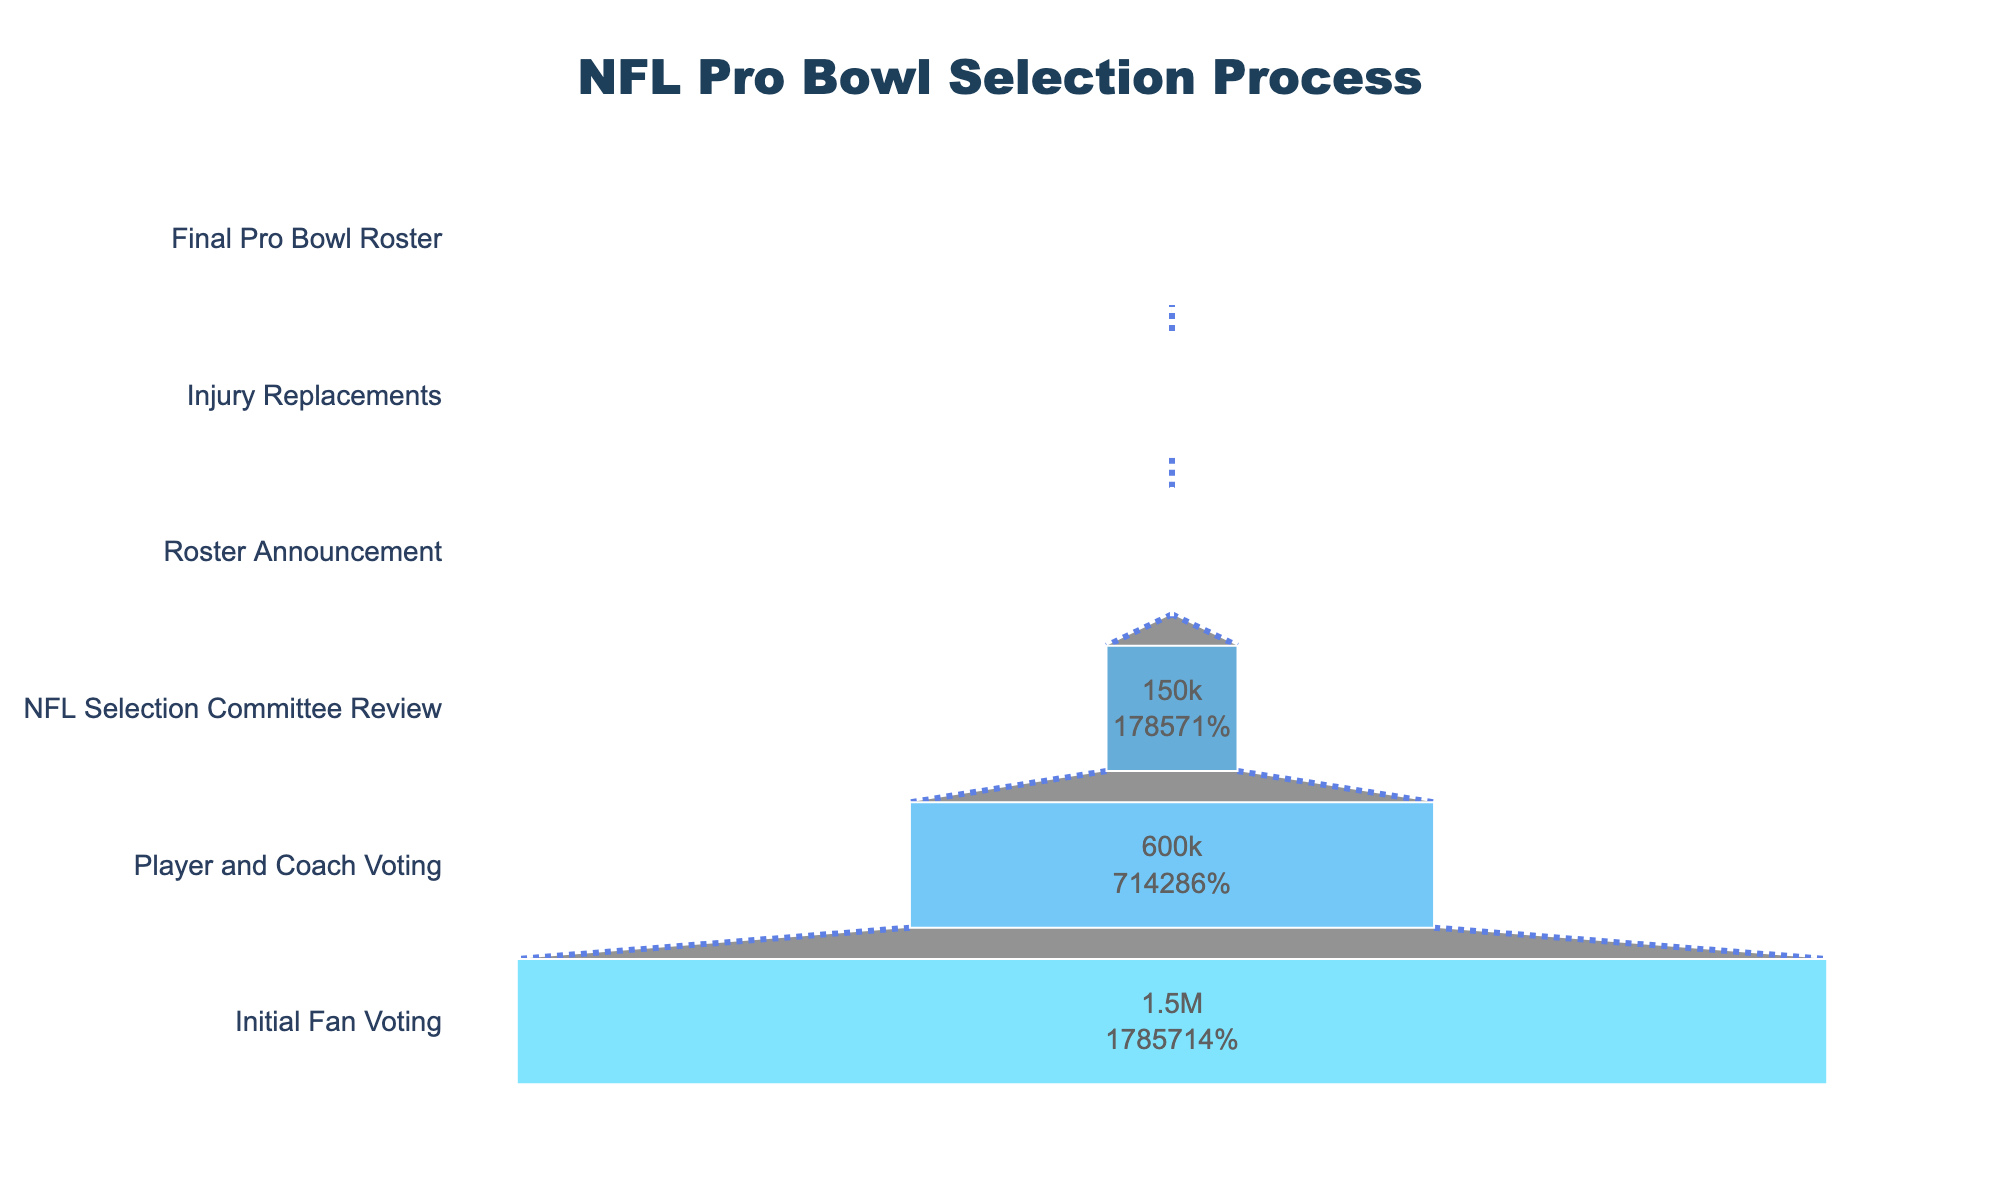What's the title of the figure? The title is usually found at the top of the chart, and it provides a summary of what the chart represents. Here, it is clearly indicated.
Answer: "NFL Pro Bowl Selection Process" How many players went through Initial Fan Voting? Look at the first stage from the top of the funnel chart where "Initial Fan Voting" is listed and check the number next to it.
Answer: 1,500,000 What percentage of players from the Player and Coach Voting stage moved to the NFL Selection Committee Review stage? Find the number of players in the "Player and Coach Voting" and "NFL Selection Committee Review" stages. Perform the division, then multiply by 100 to find the percentage. 150,000 / 600,000 * 100
Answer: 25% How many stages are visible in the funnel chart? Count the number of distinct stages listed along the y-axis of the funnel chart.
Answer: 6 How many players made it to the final Pro Bowl roster after injury replacements? Look at the "Final Pro Bowl Roster" stage and check the number next to it.
Answer: 84 How do the number of players in the Roster Announcement stage compare to those in the NFL Selection Committee Review stage? Compare the values next to the "Roster Announcement" and "NFL Selection Committee Review" stages. 88 vs. 150,000
Answer: Less than If a player is selected in the NFL Selection Committee Review stage, what's the probability that they make it to the final Pro Bowl roster? Find the number of players at the "NFL Selection Committee Review" stage and the "Final Pro Bowl Roster" stage, then perform the division and multiply by 100. 84 / 150,000 * 100
Answer: 0.056% What is the main color used for the stage with the lowest number of players? Identify the color used for the stage "Roster Announcement," which has the number 20 next to it.
Answer: Light blue What is the difference between the number of players in the Initial Fan Voting and the Final Pro Bowl Roster? Subtract the number of players in the "Final Pro Bowl Roster" from the "Initial Fan Voting". 1,500,000 - 84
Answer: 1,499,916 